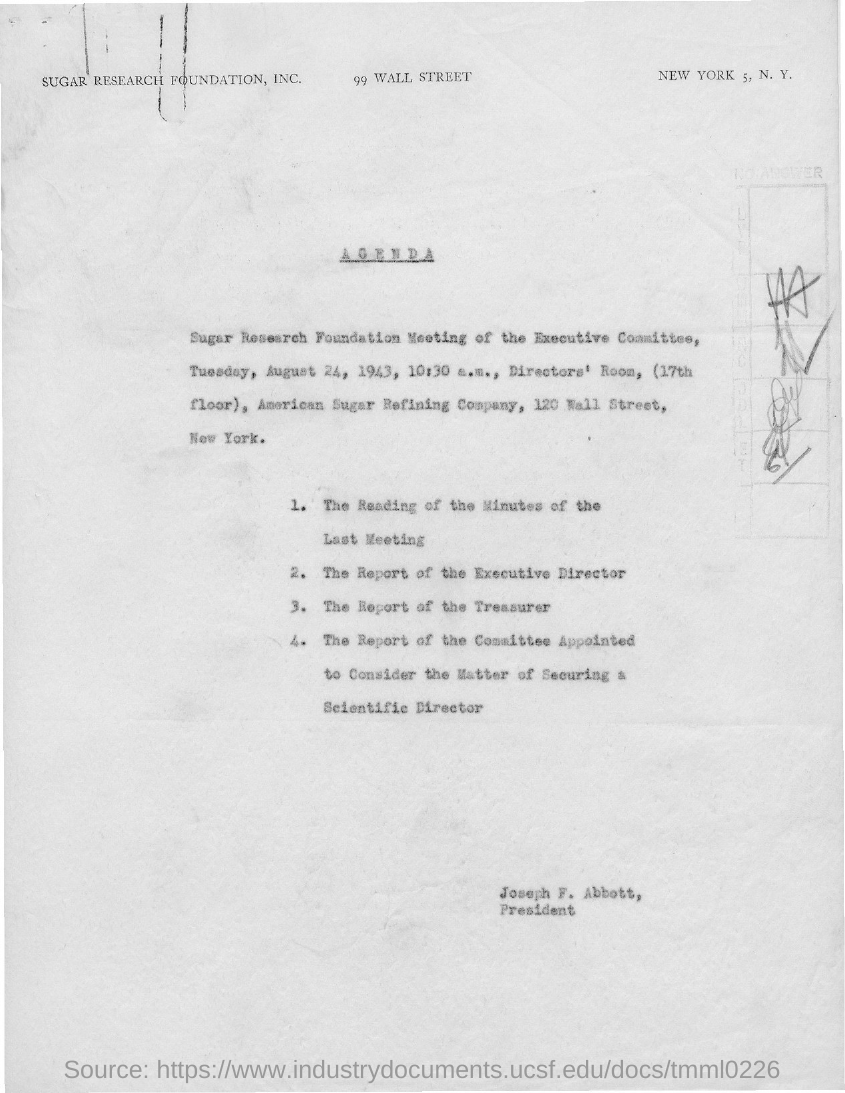Give some essential details in this illustration. The American Sugar Refining Company is mentioned in the given agenda. The Sugar Research Foundation, Inc. is the name of the foundation mentioned on the given page. The meeting was scheduled in 1943, as specified in the given agenda. The meeting was scheduled for Tuesday, as specified in the agenda. The time mentioned in the given agenda is 10:30 a.m. 